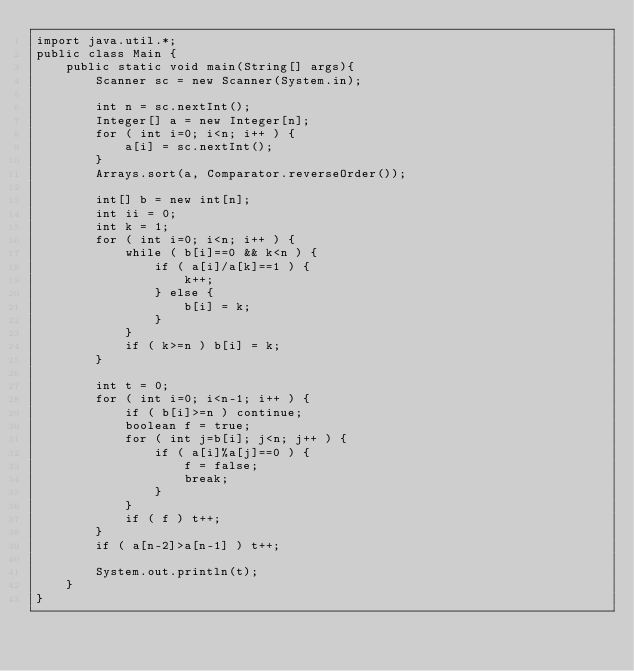Convert code to text. <code><loc_0><loc_0><loc_500><loc_500><_Java_>import java.util.*;
public class Main {
	public static void main(String[] args){
		Scanner sc = new Scanner(System.in);

		int n = sc.nextInt();
		Integer[] a = new Integer[n];
		for ( int i=0; i<n; i++ ) {
			a[i] = sc.nextInt();
		}
		Arrays.sort(a, Comparator.reverseOrder());

		int[] b = new int[n];
		int ii = 0;
		int k = 1;
		for ( int i=0; i<n; i++ ) {
			while ( b[i]==0 && k<n ) {
				if ( a[i]/a[k]==1 ) {
					k++;
				} else {
					b[i] = k;
				}
			}
			if ( k>=n ) b[i] = k;
		}

		int t = 0;
		for ( int i=0; i<n-1; i++ ) {
			if ( b[i]>=n ) continue;
			boolean f = true;
			for ( int j=b[i]; j<n; j++ ) {
				if ( a[i]%a[j]==0 ) {
					f = false;
					break;
				}
			}
			if ( f ) t++;
		}
		if ( a[n-2]>a[n-1] ) t++;

		System.out.println(t);
	}
}</code> 